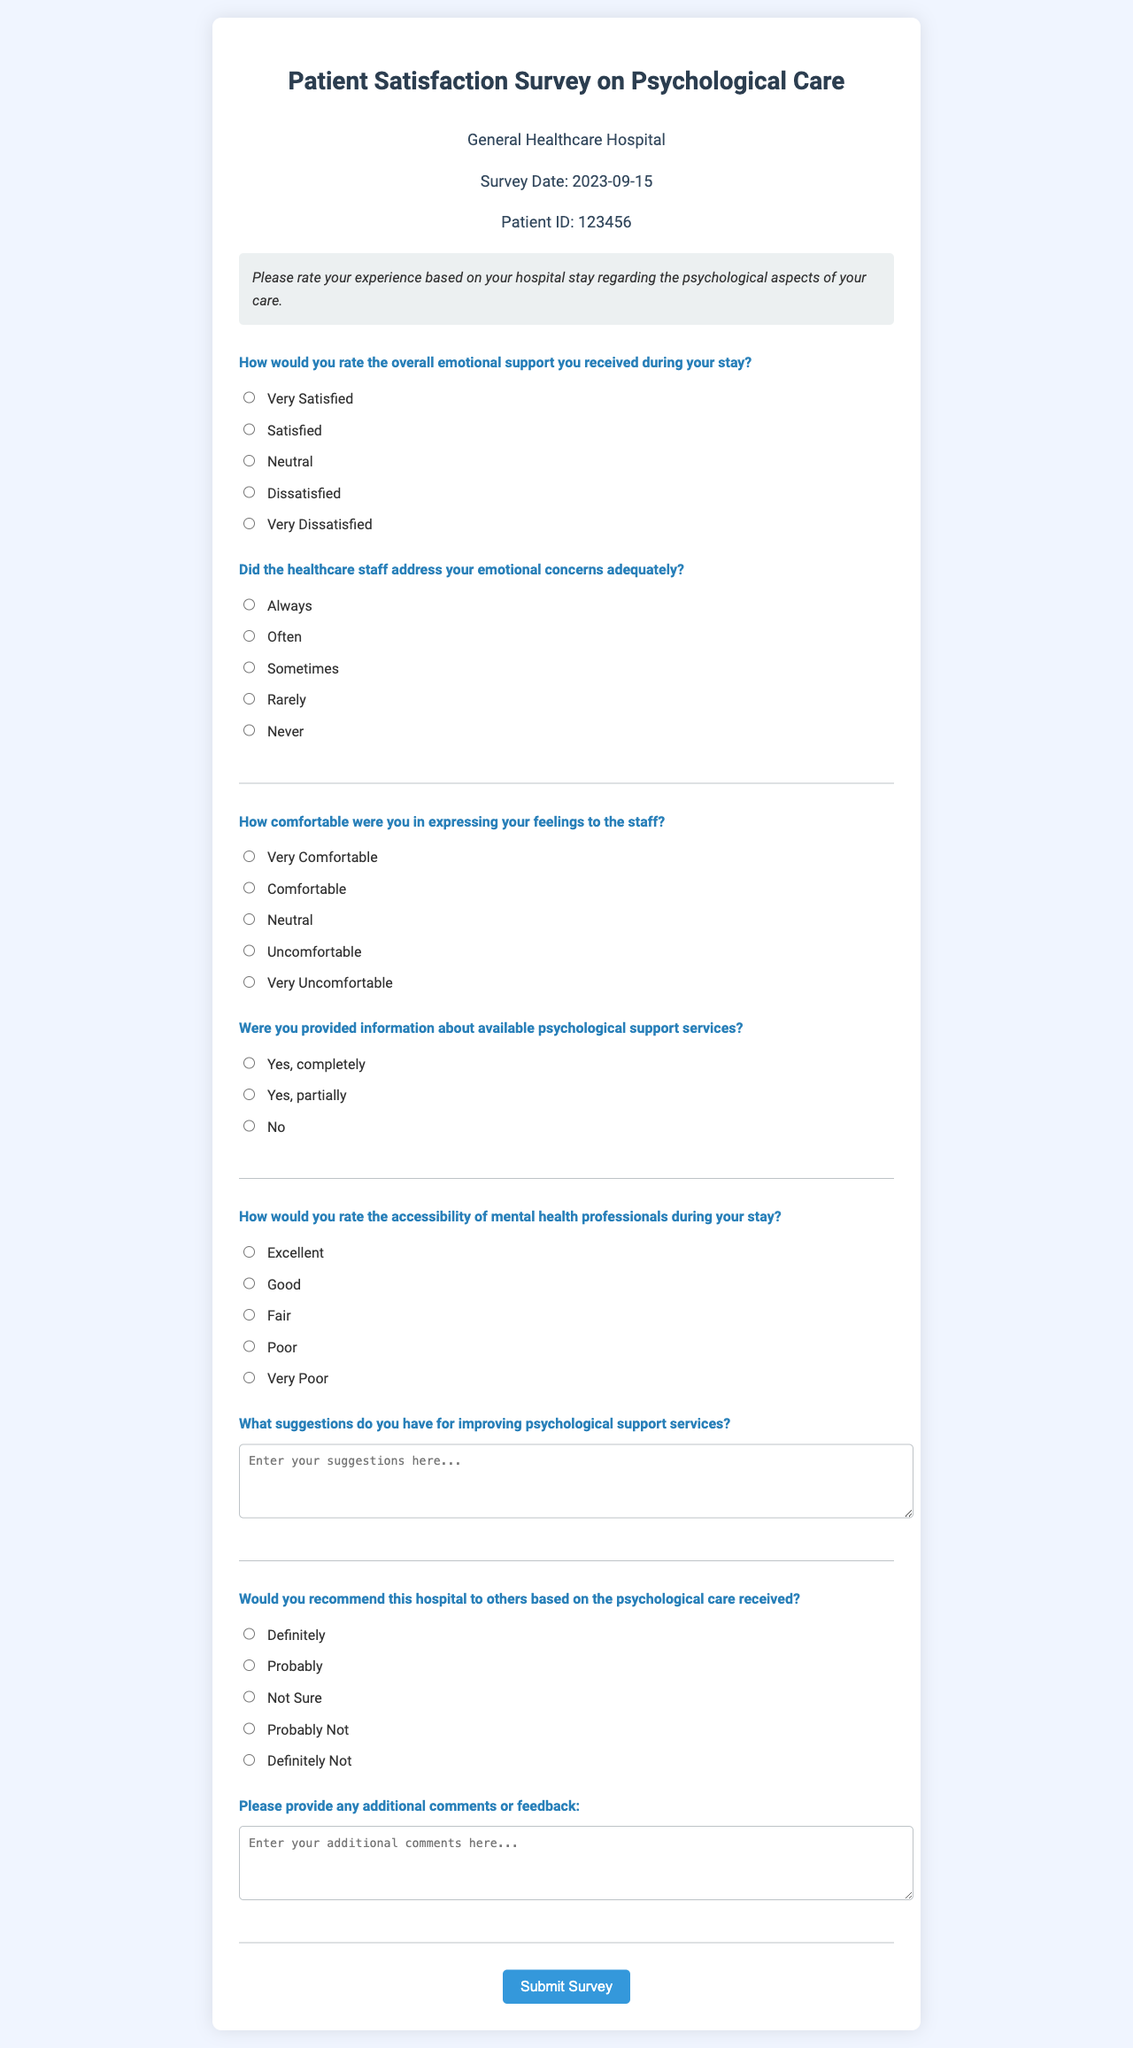What is the title of the survey? The title at the top of the document specifies the focus of the survey.
Answer: Patient Satisfaction Survey on Psychological Care What is the name of the hospital? The name of the hospital is located in the hospital information section.
Answer: General Healthcare Hospital What is the survey date? The survey date is indicated in the hospital information section of the document.
Answer: 2023-09-15 What is the Patient ID? The Patient ID is a unique identifier present in the hospital information section.
Answer: 123456 How many options are provided for rating emotional support? The number of response options available for the emotional support question is counted in the document.
Answer: Five What response indicates that emotional concerns were addressed always? The response options provided for the emotional concerns question help identify the specific answer.
Answer: Always What is one suggestion for improving psychological support services? This question asks for specific feedback, which can be found in the suggestion section.
Answer: Open-ended response Which radio button response indicates "Very Comfortable"? By examining the comfort level question, we can identify the specific text choice.
Answer: Very Comfortable How many additional comments or feedback can be provided? This question pertains to the feedback section of the document and whether it allows for multiple entries.
Answer: Open-ended response 